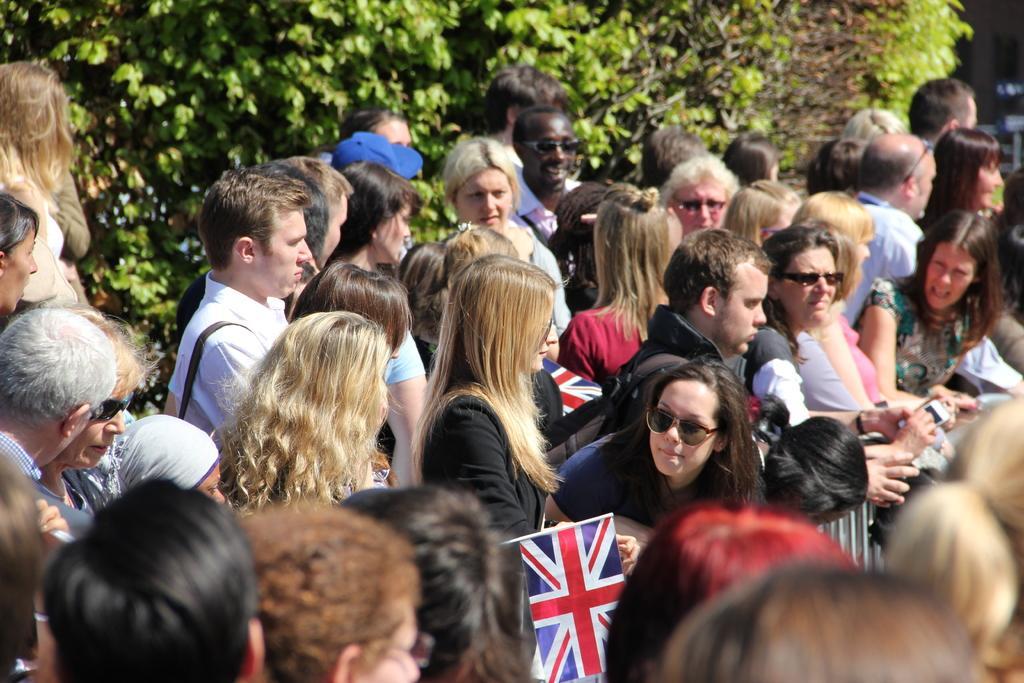In one or two sentences, can you explain what this image depicts? In this image there are many people standing. Behind them there are plants. 